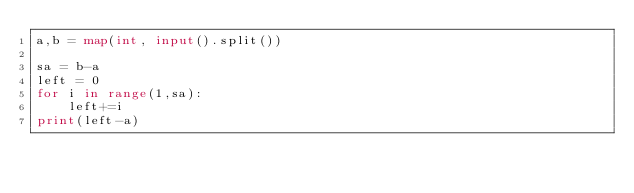Convert code to text. <code><loc_0><loc_0><loc_500><loc_500><_Python_>a,b = map(int, input().split())

sa = b-a
left = 0
for i in range(1,sa):
    left+=i
print(left-a)</code> 